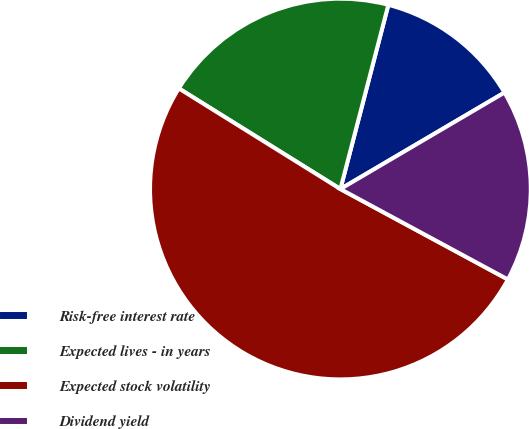<chart> <loc_0><loc_0><loc_500><loc_500><pie_chart><fcel>Risk-free interest rate<fcel>Expected lives - in years<fcel>Expected stock volatility<fcel>Dividend yield<nl><fcel>12.49%<fcel>20.19%<fcel>50.99%<fcel>16.34%<nl></chart> 